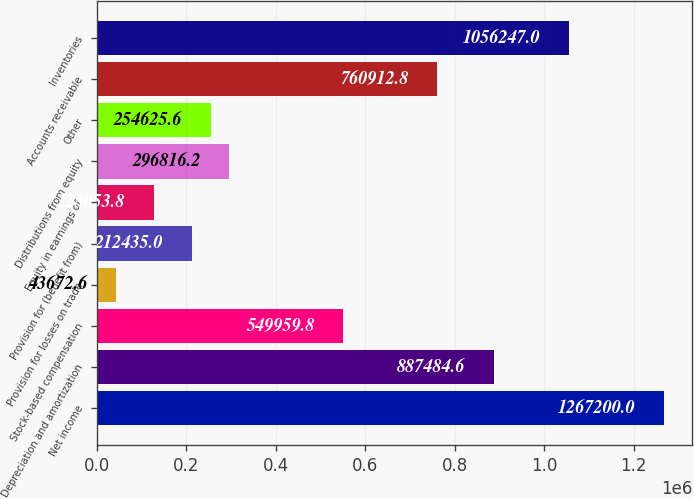<chart> <loc_0><loc_0><loc_500><loc_500><bar_chart><fcel>Net income<fcel>Depreciation and amortization<fcel>Stock-based compensation<fcel>Provision for losses on trade<fcel>Provision for (benefit from)<fcel>Equity in earnings of<fcel>Distributions from equity<fcel>Other<fcel>Accounts receivable<fcel>Inventories<nl><fcel>1.2672e+06<fcel>887485<fcel>549960<fcel>43672.6<fcel>212435<fcel>128054<fcel>296816<fcel>254626<fcel>760913<fcel>1.05625e+06<nl></chart> 